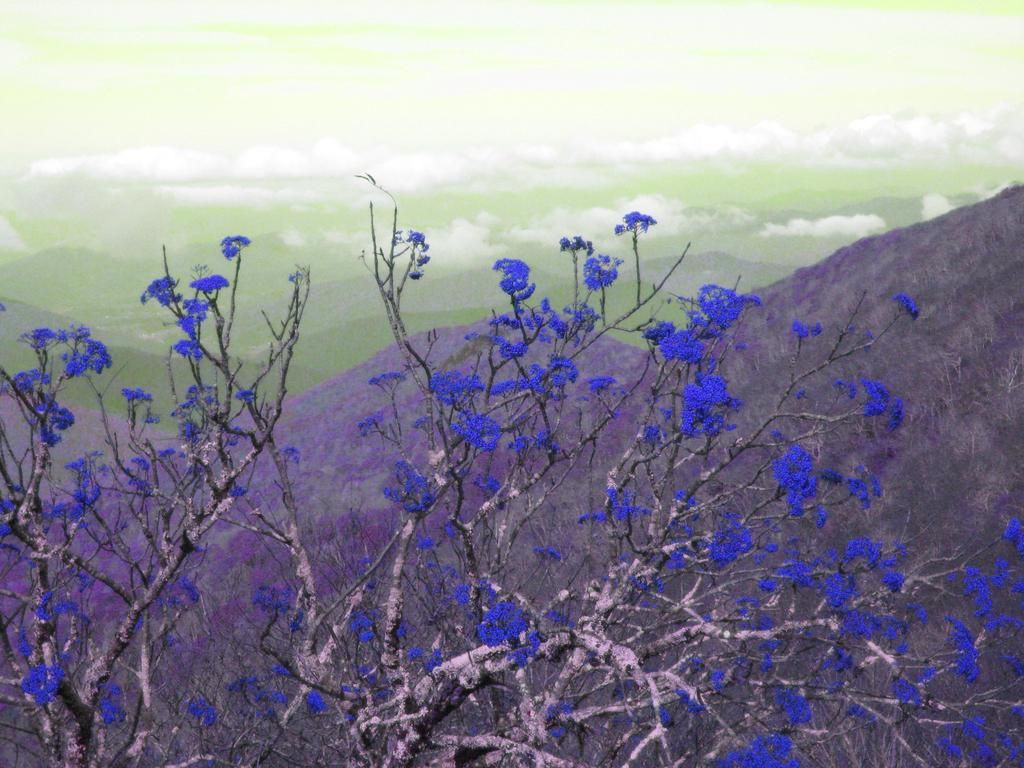What type of flowers can be seen on the tree in the image? There are purple flowers on a tree in the image. What natural features can be seen in the background of the image? Mountains are visible in the background of the image. What part of the sky is visible in the image? The sky is visible in the image. What can be observed in the sky in the image? Clouds are present in the sky. What type of trail can be seen in the image? There is no trail present in the image. What type of war is depicted in the image? There is no war depicted in the image; it features a tree with purple flowers, mountains in the background, and clouds in the sky. 